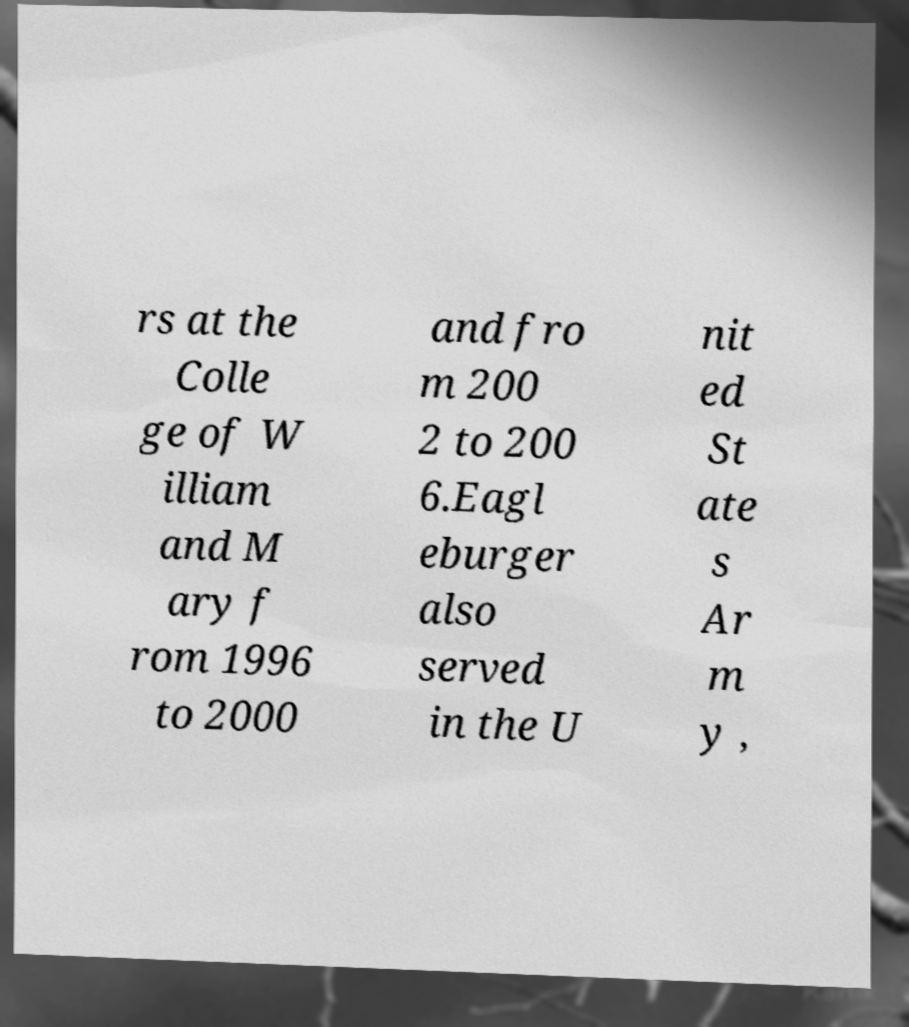Could you extract and type out the text from this image? rs at the Colle ge of W illiam and M ary f rom 1996 to 2000 and fro m 200 2 to 200 6.Eagl eburger also served in the U nit ed St ate s Ar m y , 